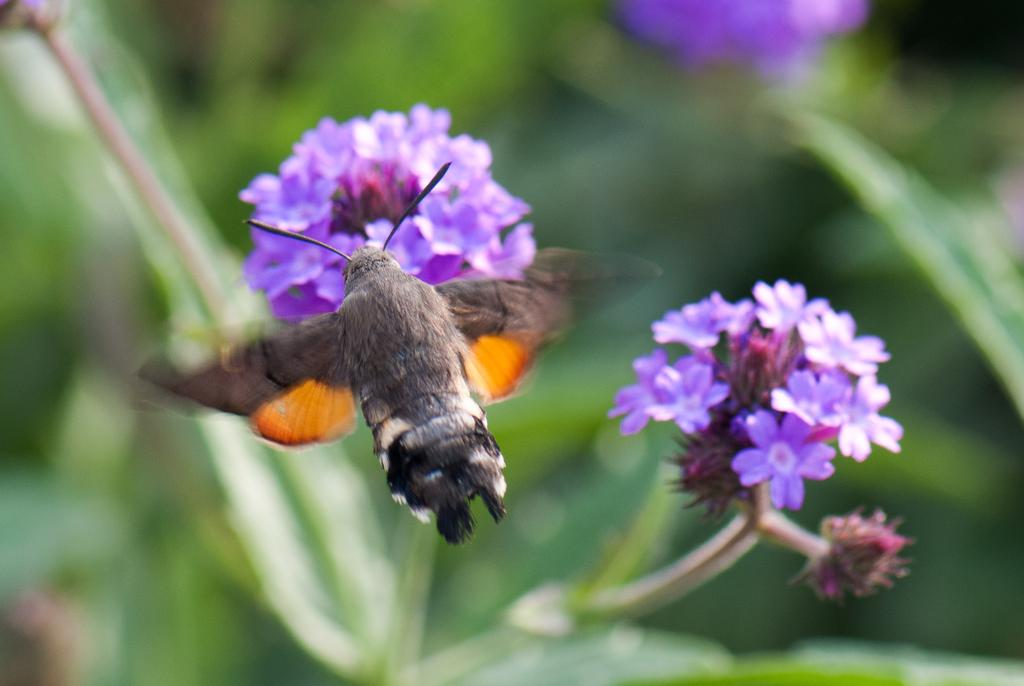What type of insect is present in the image? There is a honey bee in the image. What is the honey bee interacting with in the image? The honey bee is interacting with flowers in the image. Can you describe the background of the image? The background of the image is blurry. How many horses can be seen teaching in the image? There are no horses or teaching activities present in the image. 